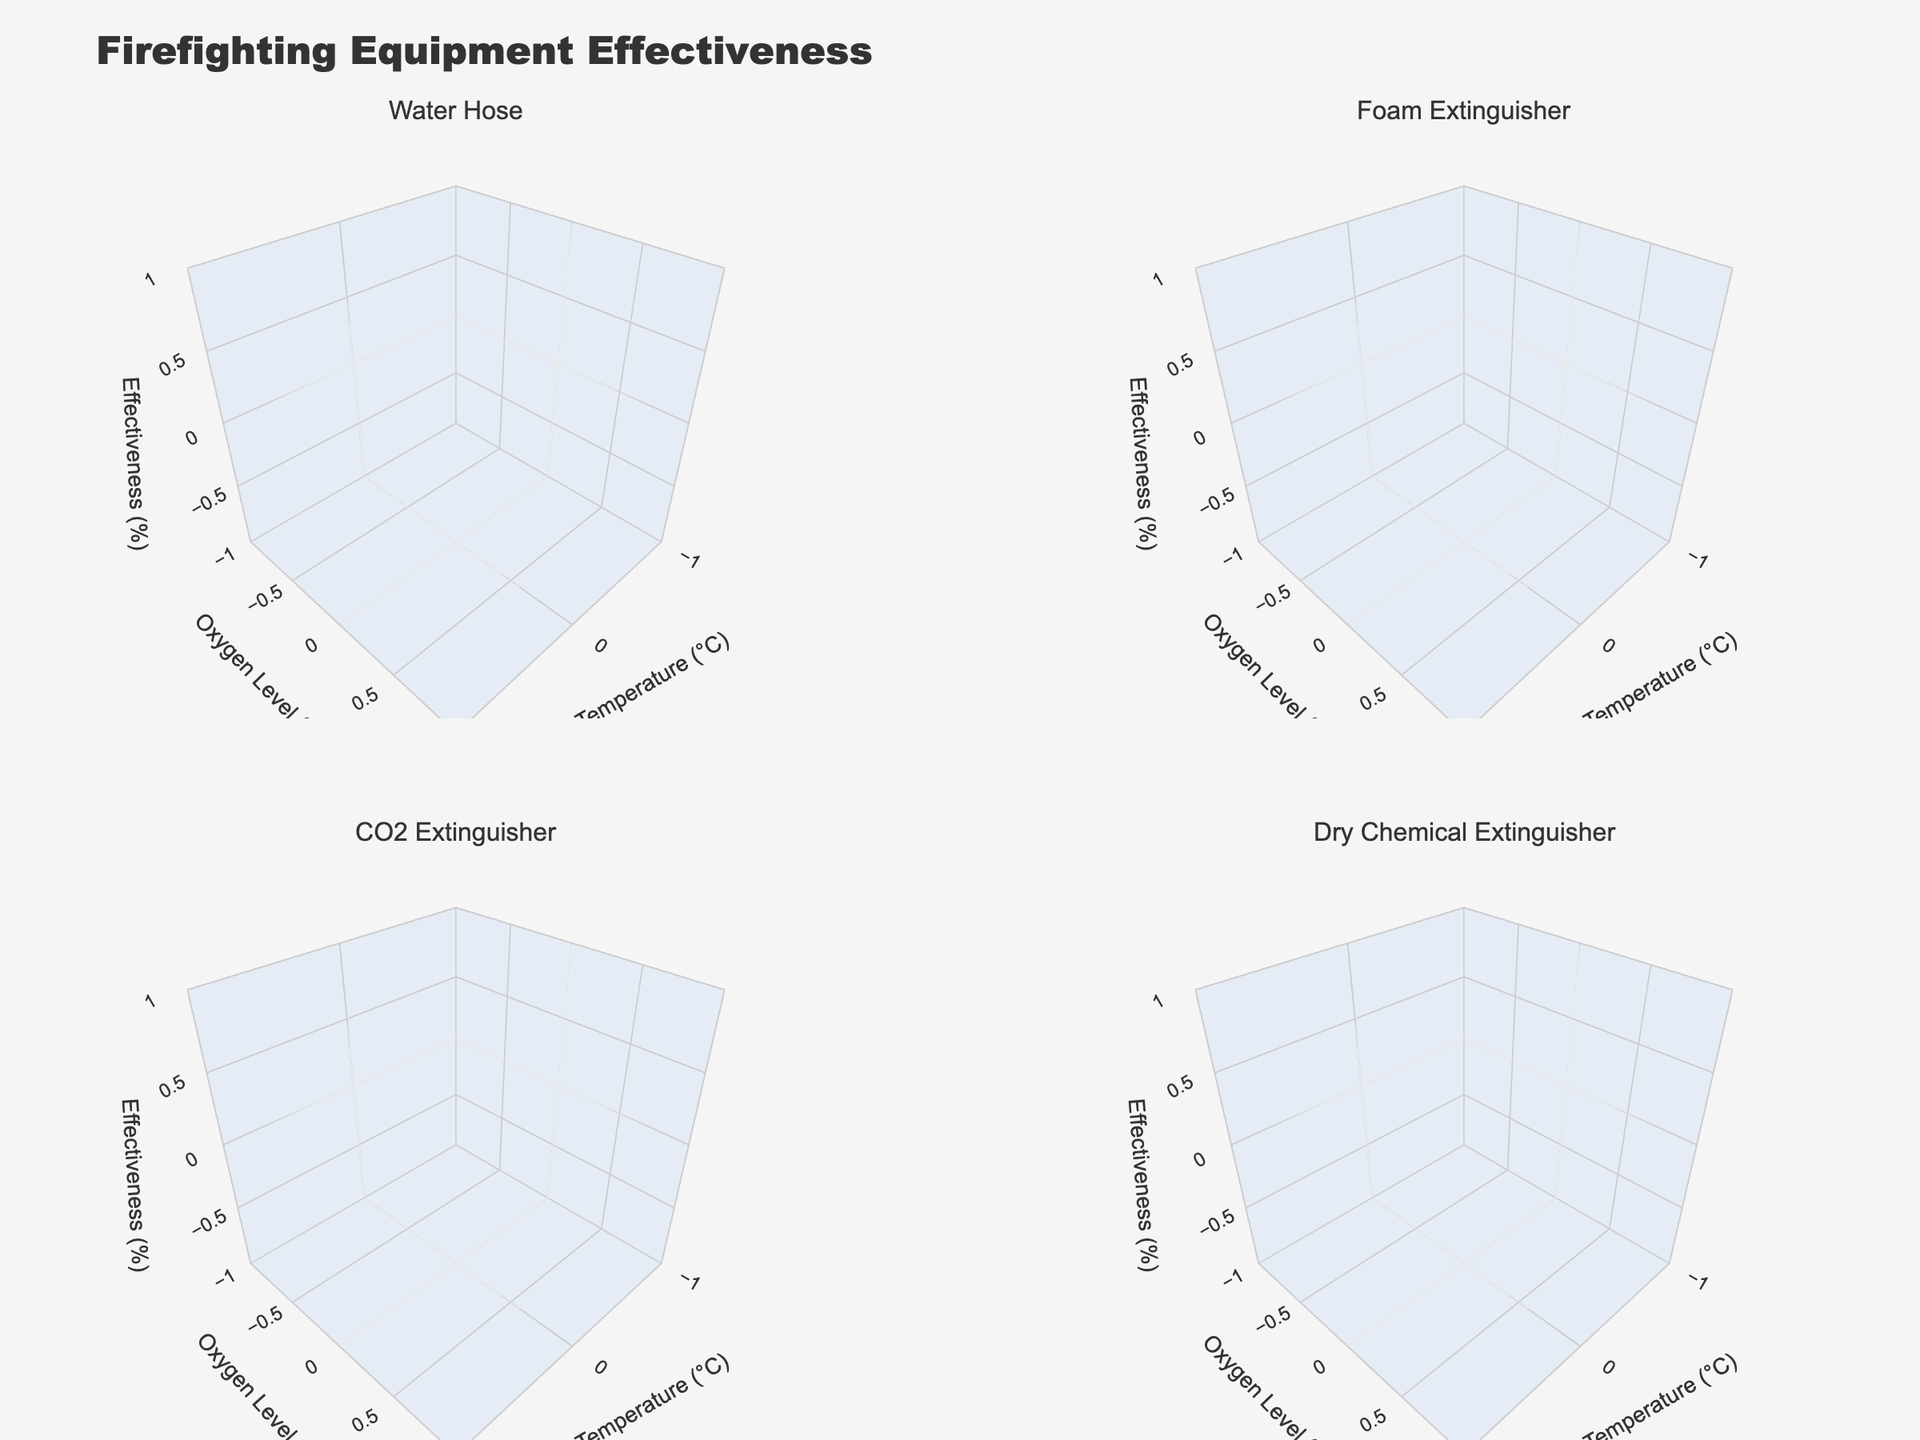How many subplots are there in the figure? The figure is a 2x2 grid of subplots. We can see that there are four surface plots displayed in the figure.
Answer: Four What is the title of the figure? The title of the figure is mentioned at the top and reads "Firefighting Equipment Effectiveness".
Answer: Firefighting Equipment Effectiveness What are the titles of the individual subplots? The titles of the individual subplots are shown above each plot and they are "Water Hose", "Foam Extinguisher", "CO2 Extinguisher", and "Dry Chemical Extinguisher".
Answer: Water Hose, Foam Extinguisher, CO2 Extinguisher, Dry Chemical Extinguisher Which firefighting equipment shows the highest effectiveness at the lowest temperature? By examining the plots, the Foam Extinguisher at 300°C shows the highest effectiveness at the lowest temperature, with an effectiveness of 95%.
Answer: Foam Extinguisher Is the effectiveness of the Water Hose greater than that of the CO2 Extinguisher at 700°C? By looking at the 3D surface plots, we see that the effectiveness of the Water Hose at 700°C is not plotted, but the CO2 extinguisher has an effectiveness of 55% at 700°C. Comparison using available data shows that the CO2 Extinguisher data at 700°C is available as effectiveness 55% and water hose data is not available.
Answer: No Does the effectiveness of the Dry Chemical Extinguisher increase or decrease with temperature? Observing the Dry Chemical Extinguisher subplot, we see effectiveness decreases as temperature increases from 400°C to 1000°C.
Answer: Decrease What is the general trend in effectiveness of the Water Hose with increasing temperature? The subplot for the Water Hose shows that as the temperature increases from 500°C to 1200°C, the effectiveness decreases from 85% to 45%.
Answer: Decrease Which scenario does the Dry Chemical Extinguisher perform best in, according to the figure? The subplot for the Dry Chemical Extinguisher shows that it is most effective in the "Kitchen Fire" scenario with an effectiveness of 92%.
Answer: Kitchen Fire In which scenario does the CO2 Extinguisher have the highest effectiveness, and what is that effectiveness? The subplot for the CO2 Extinguisher shows that it has the highest effectiveness in the "Electrical Fire" scenario with an effectiveness of 90%.
Answer: Electrical Fire, 90% Comparing Water Hose and Foam Extinguisher, which one is more effective at around 600°C? Based on the plots, the effectiveness of Water Hose at 600°C is not available, but the Foam Extinguisher is at 80%. Therefore, Foam Extinguisher is more effective at around 600°C.
Answer: Foam Extinguisher 